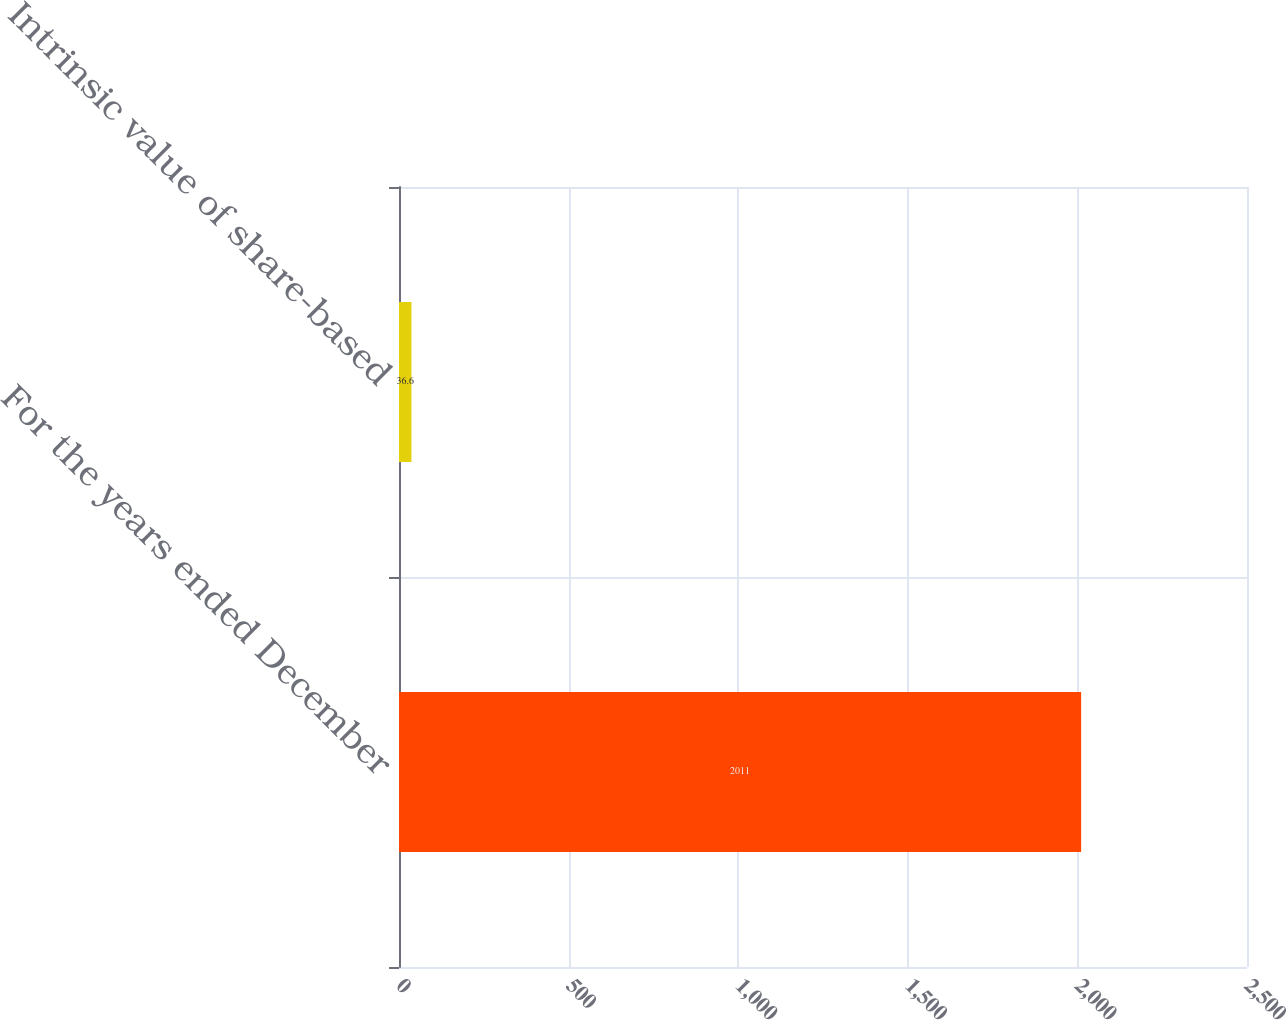Convert chart. <chart><loc_0><loc_0><loc_500><loc_500><bar_chart><fcel>For the years ended December<fcel>Intrinsic value of share-based<nl><fcel>2011<fcel>36.6<nl></chart> 